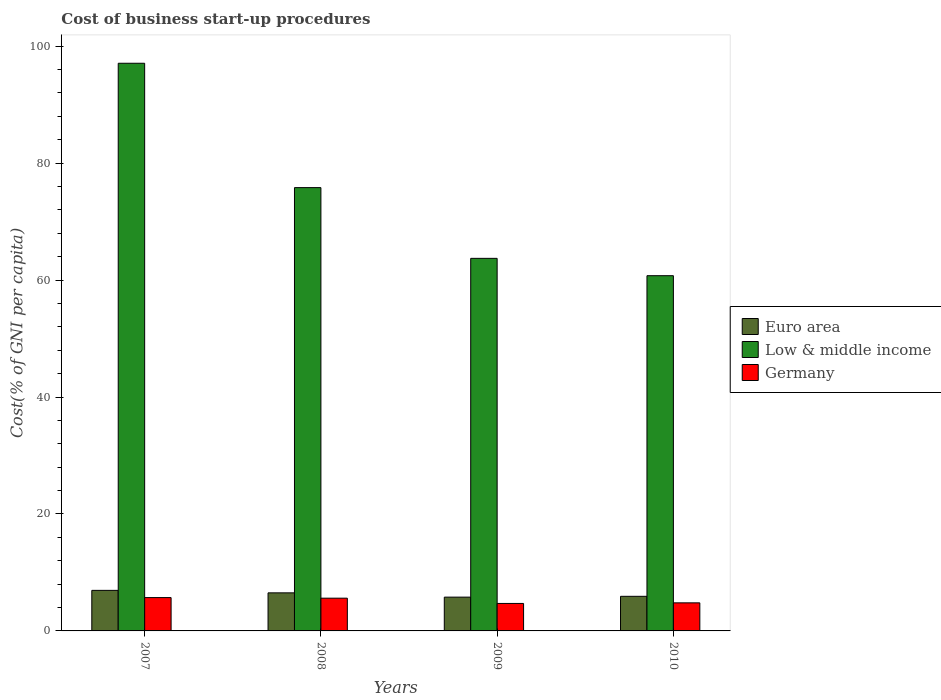How many different coloured bars are there?
Offer a terse response. 3. How many groups of bars are there?
Make the answer very short. 4. Are the number of bars per tick equal to the number of legend labels?
Make the answer very short. Yes. How many bars are there on the 4th tick from the left?
Provide a succinct answer. 3. How many bars are there on the 2nd tick from the right?
Make the answer very short. 3. What is the label of the 1st group of bars from the left?
Offer a very short reply. 2007. In how many cases, is the number of bars for a given year not equal to the number of legend labels?
Keep it short and to the point. 0. Across all years, what is the maximum cost of business start-up procedures in Low & middle income?
Your answer should be very brief. 97.08. In which year was the cost of business start-up procedures in Low & middle income maximum?
Ensure brevity in your answer.  2007. In which year was the cost of business start-up procedures in Low & middle income minimum?
Your answer should be compact. 2010. What is the total cost of business start-up procedures in Low & middle income in the graph?
Make the answer very short. 297.35. What is the difference between the cost of business start-up procedures in Low & middle income in 2007 and that in 2008?
Make the answer very short. 21.27. What is the difference between the cost of business start-up procedures in Euro area in 2008 and the cost of business start-up procedures in Germany in 2009?
Provide a short and direct response. 1.81. What is the average cost of business start-up procedures in Euro area per year?
Keep it short and to the point. 6.29. In the year 2009, what is the difference between the cost of business start-up procedures in Euro area and cost of business start-up procedures in Germany?
Give a very brief answer. 1.08. What is the ratio of the cost of business start-up procedures in Germany in 2008 to that in 2009?
Make the answer very short. 1.19. Is the cost of business start-up procedures in Low & middle income in 2008 less than that in 2009?
Provide a succinct answer. No. What is the difference between the highest and the second highest cost of business start-up procedures in Euro area?
Provide a short and direct response. 0.42. What is the difference between the highest and the lowest cost of business start-up procedures in Low & middle income?
Your response must be concise. 36.33. In how many years, is the cost of business start-up procedures in Germany greater than the average cost of business start-up procedures in Germany taken over all years?
Your answer should be compact. 2. What does the 1st bar from the left in 2007 represents?
Your answer should be very brief. Euro area. What does the 2nd bar from the right in 2008 represents?
Provide a succinct answer. Low & middle income. Is it the case that in every year, the sum of the cost of business start-up procedures in Germany and cost of business start-up procedures in Low & middle income is greater than the cost of business start-up procedures in Euro area?
Ensure brevity in your answer.  Yes. How many years are there in the graph?
Provide a succinct answer. 4. What is the difference between two consecutive major ticks on the Y-axis?
Offer a terse response. 20. Are the values on the major ticks of Y-axis written in scientific E-notation?
Keep it short and to the point. No. Does the graph contain any zero values?
Provide a succinct answer. No. Does the graph contain grids?
Provide a succinct answer. No. Where does the legend appear in the graph?
Make the answer very short. Center right. How many legend labels are there?
Ensure brevity in your answer.  3. How are the legend labels stacked?
Your answer should be very brief. Vertical. What is the title of the graph?
Provide a short and direct response. Cost of business start-up procedures. Does "Bahrain" appear as one of the legend labels in the graph?
Your response must be concise. No. What is the label or title of the X-axis?
Give a very brief answer. Years. What is the label or title of the Y-axis?
Your response must be concise. Cost(% of GNI per capita). What is the Cost(% of GNI per capita) in Euro area in 2007?
Offer a very short reply. 6.94. What is the Cost(% of GNI per capita) of Low & middle income in 2007?
Your answer should be very brief. 97.08. What is the Cost(% of GNI per capita) of Euro area in 2008?
Keep it short and to the point. 6.51. What is the Cost(% of GNI per capita) in Low & middle income in 2008?
Make the answer very short. 75.81. What is the Cost(% of GNI per capita) in Germany in 2008?
Give a very brief answer. 5.6. What is the Cost(% of GNI per capita) of Euro area in 2009?
Keep it short and to the point. 5.78. What is the Cost(% of GNI per capita) in Low & middle income in 2009?
Your response must be concise. 63.72. What is the Cost(% of GNI per capita) in Euro area in 2010?
Keep it short and to the point. 5.92. What is the Cost(% of GNI per capita) of Low & middle income in 2010?
Ensure brevity in your answer.  60.75. Across all years, what is the maximum Cost(% of GNI per capita) of Euro area?
Provide a short and direct response. 6.94. Across all years, what is the maximum Cost(% of GNI per capita) of Low & middle income?
Provide a short and direct response. 97.08. Across all years, what is the maximum Cost(% of GNI per capita) in Germany?
Your response must be concise. 5.7. Across all years, what is the minimum Cost(% of GNI per capita) of Euro area?
Keep it short and to the point. 5.78. Across all years, what is the minimum Cost(% of GNI per capita) in Low & middle income?
Provide a short and direct response. 60.75. What is the total Cost(% of GNI per capita) of Euro area in the graph?
Your answer should be compact. 25.14. What is the total Cost(% of GNI per capita) in Low & middle income in the graph?
Provide a short and direct response. 297.35. What is the total Cost(% of GNI per capita) of Germany in the graph?
Your answer should be compact. 20.8. What is the difference between the Cost(% of GNI per capita) of Euro area in 2007 and that in 2008?
Your answer should be very brief. 0.42. What is the difference between the Cost(% of GNI per capita) in Low & middle income in 2007 and that in 2008?
Make the answer very short. 21.27. What is the difference between the Cost(% of GNI per capita) in Germany in 2007 and that in 2008?
Keep it short and to the point. 0.1. What is the difference between the Cost(% of GNI per capita) in Euro area in 2007 and that in 2009?
Give a very brief answer. 1.16. What is the difference between the Cost(% of GNI per capita) in Low & middle income in 2007 and that in 2009?
Your answer should be compact. 33.36. What is the difference between the Cost(% of GNI per capita) of Germany in 2007 and that in 2009?
Your answer should be compact. 1. What is the difference between the Cost(% of GNI per capita) in Euro area in 2007 and that in 2010?
Your answer should be compact. 1.02. What is the difference between the Cost(% of GNI per capita) in Low & middle income in 2007 and that in 2010?
Your response must be concise. 36.33. What is the difference between the Cost(% of GNI per capita) of Germany in 2007 and that in 2010?
Keep it short and to the point. 0.9. What is the difference between the Cost(% of GNI per capita) of Euro area in 2008 and that in 2009?
Keep it short and to the point. 0.73. What is the difference between the Cost(% of GNI per capita) in Low & middle income in 2008 and that in 2009?
Your answer should be very brief. 12.1. What is the difference between the Cost(% of GNI per capita) in Euro area in 2008 and that in 2010?
Offer a terse response. 0.59. What is the difference between the Cost(% of GNI per capita) in Low & middle income in 2008 and that in 2010?
Offer a terse response. 15.06. What is the difference between the Cost(% of GNI per capita) in Germany in 2008 and that in 2010?
Your answer should be compact. 0.8. What is the difference between the Cost(% of GNI per capita) of Euro area in 2009 and that in 2010?
Your answer should be very brief. -0.14. What is the difference between the Cost(% of GNI per capita) in Low & middle income in 2009 and that in 2010?
Your response must be concise. 2.97. What is the difference between the Cost(% of GNI per capita) of Euro area in 2007 and the Cost(% of GNI per capita) of Low & middle income in 2008?
Give a very brief answer. -68.88. What is the difference between the Cost(% of GNI per capita) of Euro area in 2007 and the Cost(% of GNI per capita) of Germany in 2008?
Ensure brevity in your answer.  1.34. What is the difference between the Cost(% of GNI per capita) in Low & middle income in 2007 and the Cost(% of GNI per capita) in Germany in 2008?
Give a very brief answer. 91.48. What is the difference between the Cost(% of GNI per capita) in Euro area in 2007 and the Cost(% of GNI per capita) in Low & middle income in 2009?
Provide a succinct answer. -56.78. What is the difference between the Cost(% of GNI per capita) of Euro area in 2007 and the Cost(% of GNI per capita) of Germany in 2009?
Your answer should be very brief. 2.24. What is the difference between the Cost(% of GNI per capita) of Low & middle income in 2007 and the Cost(% of GNI per capita) of Germany in 2009?
Offer a very short reply. 92.38. What is the difference between the Cost(% of GNI per capita) of Euro area in 2007 and the Cost(% of GNI per capita) of Low & middle income in 2010?
Give a very brief answer. -53.81. What is the difference between the Cost(% of GNI per capita) of Euro area in 2007 and the Cost(% of GNI per capita) of Germany in 2010?
Your answer should be compact. 2.14. What is the difference between the Cost(% of GNI per capita) of Low & middle income in 2007 and the Cost(% of GNI per capita) of Germany in 2010?
Offer a very short reply. 92.28. What is the difference between the Cost(% of GNI per capita) of Euro area in 2008 and the Cost(% of GNI per capita) of Low & middle income in 2009?
Offer a terse response. -57.2. What is the difference between the Cost(% of GNI per capita) of Euro area in 2008 and the Cost(% of GNI per capita) of Germany in 2009?
Ensure brevity in your answer.  1.81. What is the difference between the Cost(% of GNI per capita) of Low & middle income in 2008 and the Cost(% of GNI per capita) of Germany in 2009?
Keep it short and to the point. 71.11. What is the difference between the Cost(% of GNI per capita) of Euro area in 2008 and the Cost(% of GNI per capita) of Low & middle income in 2010?
Your response must be concise. -54.24. What is the difference between the Cost(% of GNI per capita) in Euro area in 2008 and the Cost(% of GNI per capita) in Germany in 2010?
Make the answer very short. 1.71. What is the difference between the Cost(% of GNI per capita) in Low & middle income in 2008 and the Cost(% of GNI per capita) in Germany in 2010?
Offer a terse response. 71.01. What is the difference between the Cost(% of GNI per capita) in Euro area in 2009 and the Cost(% of GNI per capita) in Low & middle income in 2010?
Provide a succinct answer. -54.97. What is the difference between the Cost(% of GNI per capita) in Euro area in 2009 and the Cost(% of GNI per capita) in Germany in 2010?
Offer a terse response. 0.98. What is the difference between the Cost(% of GNI per capita) of Low & middle income in 2009 and the Cost(% of GNI per capita) of Germany in 2010?
Provide a short and direct response. 58.92. What is the average Cost(% of GNI per capita) in Euro area per year?
Your response must be concise. 6.29. What is the average Cost(% of GNI per capita) of Low & middle income per year?
Your answer should be compact. 74.34. In the year 2007, what is the difference between the Cost(% of GNI per capita) in Euro area and Cost(% of GNI per capita) in Low & middle income?
Provide a short and direct response. -90.14. In the year 2007, what is the difference between the Cost(% of GNI per capita) in Euro area and Cost(% of GNI per capita) in Germany?
Your response must be concise. 1.24. In the year 2007, what is the difference between the Cost(% of GNI per capita) in Low & middle income and Cost(% of GNI per capita) in Germany?
Ensure brevity in your answer.  91.38. In the year 2008, what is the difference between the Cost(% of GNI per capita) of Euro area and Cost(% of GNI per capita) of Low & middle income?
Offer a very short reply. -69.3. In the year 2008, what is the difference between the Cost(% of GNI per capita) of Euro area and Cost(% of GNI per capita) of Germany?
Your response must be concise. 0.91. In the year 2008, what is the difference between the Cost(% of GNI per capita) in Low & middle income and Cost(% of GNI per capita) in Germany?
Make the answer very short. 70.21. In the year 2009, what is the difference between the Cost(% of GNI per capita) of Euro area and Cost(% of GNI per capita) of Low & middle income?
Give a very brief answer. -57.94. In the year 2009, what is the difference between the Cost(% of GNI per capita) in Euro area and Cost(% of GNI per capita) in Germany?
Offer a very short reply. 1.08. In the year 2009, what is the difference between the Cost(% of GNI per capita) in Low & middle income and Cost(% of GNI per capita) in Germany?
Provide a succinct answer. 59.02. In the year 2010, what is the difference between the Cost(% of GNI per capita) of Euro area and Cost(% of GNI per capita) of Low & middle income?
Provide a short and direct response. -54.83. In the year 2010, what is the difference between the Cost(% of GNI per capita) in Euro area and Cost(% of GNI per capita) in Germany?
Offer a terse response. 1.12. In the year 2010, what is the difference between the Cost(% of GNI per capita) of Low & middle income and Cost(% of GNI per capita) of Germany?
Ensure brevity in your answer.  55.95. What is the ratio of the Cost(% of GNI per capita) of Euro area in 2007 to that in 2008?
Provide a short and direct response. 1.07. What is the ratio of the Cost(% of GNI per capita) in Low & middle income in 2007 to that in 2008?
Provide a succinct answer. 1.28. What is the ratio of the Cost(% of GNI per capita) of Germany in 2007 to that in 2008?
Your response must be concise. 1.02. What is the ratio of the Cost(% of GNI per capita) of Euro area in 2007 to that in 2009?
Ensure brevity in your answer.  1.2. What is the ratio of the Cost(% of GNI per capita) of Low & middle income in 2007 to that in 2009?
Provide a short and direct response. 1.52. What is the ratio of the Cost(% of GNI per capita) of Germany in 2007 to that in 2009?
Provide a short and direct response. 1.21. What is the ratio of the Cost(% of GNI per capita) of Euro area in 2007 to that in 2010?
Your response must be concise. 1.17. What is the ratio of the Cost(% of GNI per capita) of Low & middle income in 2007 to that in 2010?
Offer a very short reply. 1.6. What is the ratio of the Cost(% of GNI per capita) in Germany in 2007 to that in 2010?
Offer a very short reply. 1.19. What is the ratio of the Cost(% of GNI per capita) of Euro area in 2008 to that in 2009?
Make the answer very short. 1.13. What is the ratio of the Cost(% of GNI per capita) in Low & middle income in 2008 to that in 2009?
Offer a very short reply. 1.19. What is the ratio of the Cost(% of GNI per capita) in Germany in 2008 to that in 2009?
Offer a terse response. 1.19. What is the ratio of the Cost(% of GNI per capita) of Euro area in 2008 to that in 2010?
Your response must be concise. 1.1. What is the ratio of the Cost(% of GNI per capita) in Low & middle income in 2008 to that in 2010?
Offer a terse response. 1.25. What is the ratio of the Cost(% of GNI per capita) in Euro area in 2009 to that in 2010?
Provide a short and direct response. 0.98. What is the ratio of the Cost(% of GNI per capita) in Low & middle income in 2009 to that in 2010?
Offer a terse response. 1.05. What is the ratio of the Cost(% of GNI per capita) in Germany in 2009 to that in 2010?
Keep it short and to the point. 0.98. What is the difference between the highest and the second highest Cost(% of GNI per capita) in Euro area?
Your response must be concise. 0.42. What is the difference between the highest and the second highest Cost(% of GNI per capita) of Low & middle income?
Ensure brevity in your answer.  21.27. What is the difference between the highest and the second highest Cost(% of GNI per capita) in Germany?
Provide a short and direct response. 0.1. What is the difference between the highest and the lowest Cost(% of GNI per capita) of Euro area?
Offer a terse response. 1.16. What is the difference between the highest and the lowest Cost(% of GNI per capita) in Low & middle income?
Your answer should be compact. 36.33. 